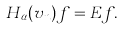Convert formula to latex. <formula><loc_0><loc_0><loc_500><loc_500>H _ { \alpha } ( v _ { n } ) f = E f .</formula> 